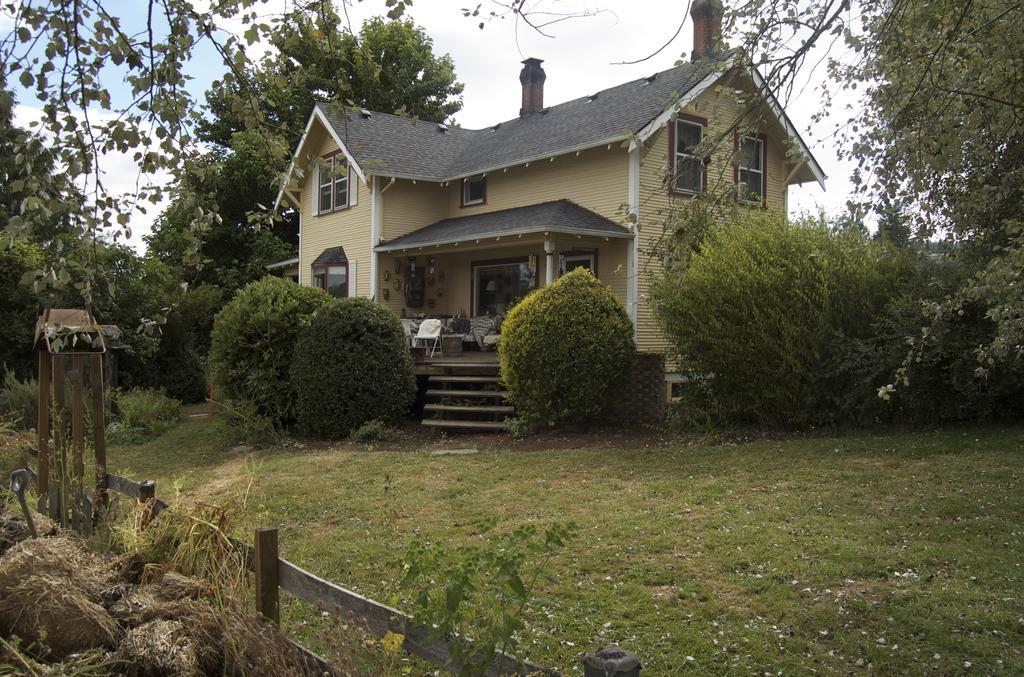How would you summarize this image in a sentence or two? In this picture we can see a house. There are few chairs and a table in this house. We can see a few trees on the right and left side of the image. Sky is blue in color and cloudy. 